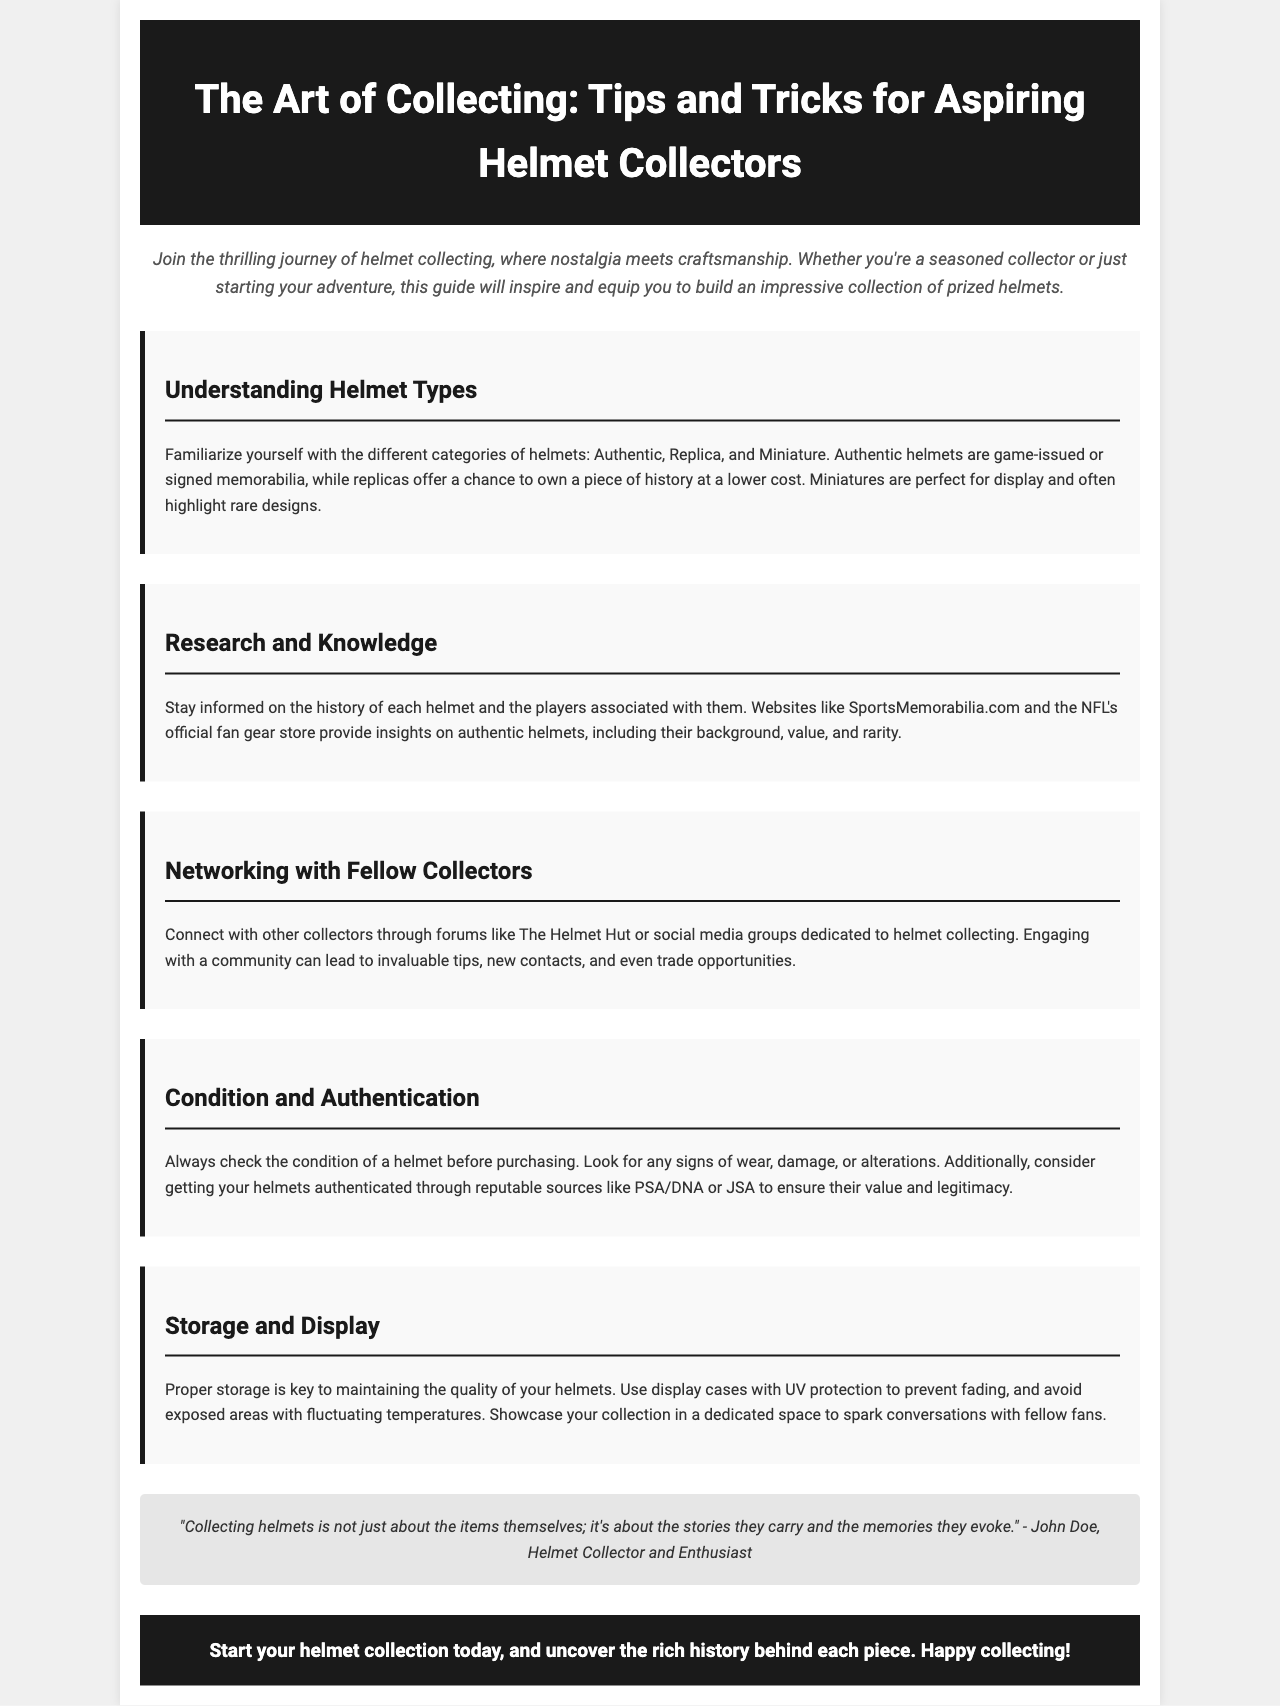what are the three types of helmets mentioned? The document states the three types of helmets are Authentic, Replica, and Miniature.
Answer: Authentic, Replica, and Miniature which website is referenced for helmet history? The brochure suggests visiting SportsMemorabilia.com for information on helmet history.
Answer: SportsMemorabilia.com what should you check before purchasing a helmet? It advises to check the condition of the helmet before buying.
Answer: Condition who offers authentication services for helmets? The document mentions PSA/DNA and JSA as reputable sources for authentication.
Answer: PSA/DNA or JSA what is one tip for displaying helmets? The brochure recommends using display cases with UV protection to maintain quality.
Answer: UV protection how can collectors connect with each other? The document suggests using forums like The Helmet Hut or social media groups.
Answer: Forums or social media groups what is emphasized as the main focus of helmet collecting? The text highlights that collecting helmets is about the stories and memories they evoke.
Answer: Stories and memories who is quoted in the brochure? The document quotes John Doe, a helmet collector and enthusiast.
Answer: John Doe 